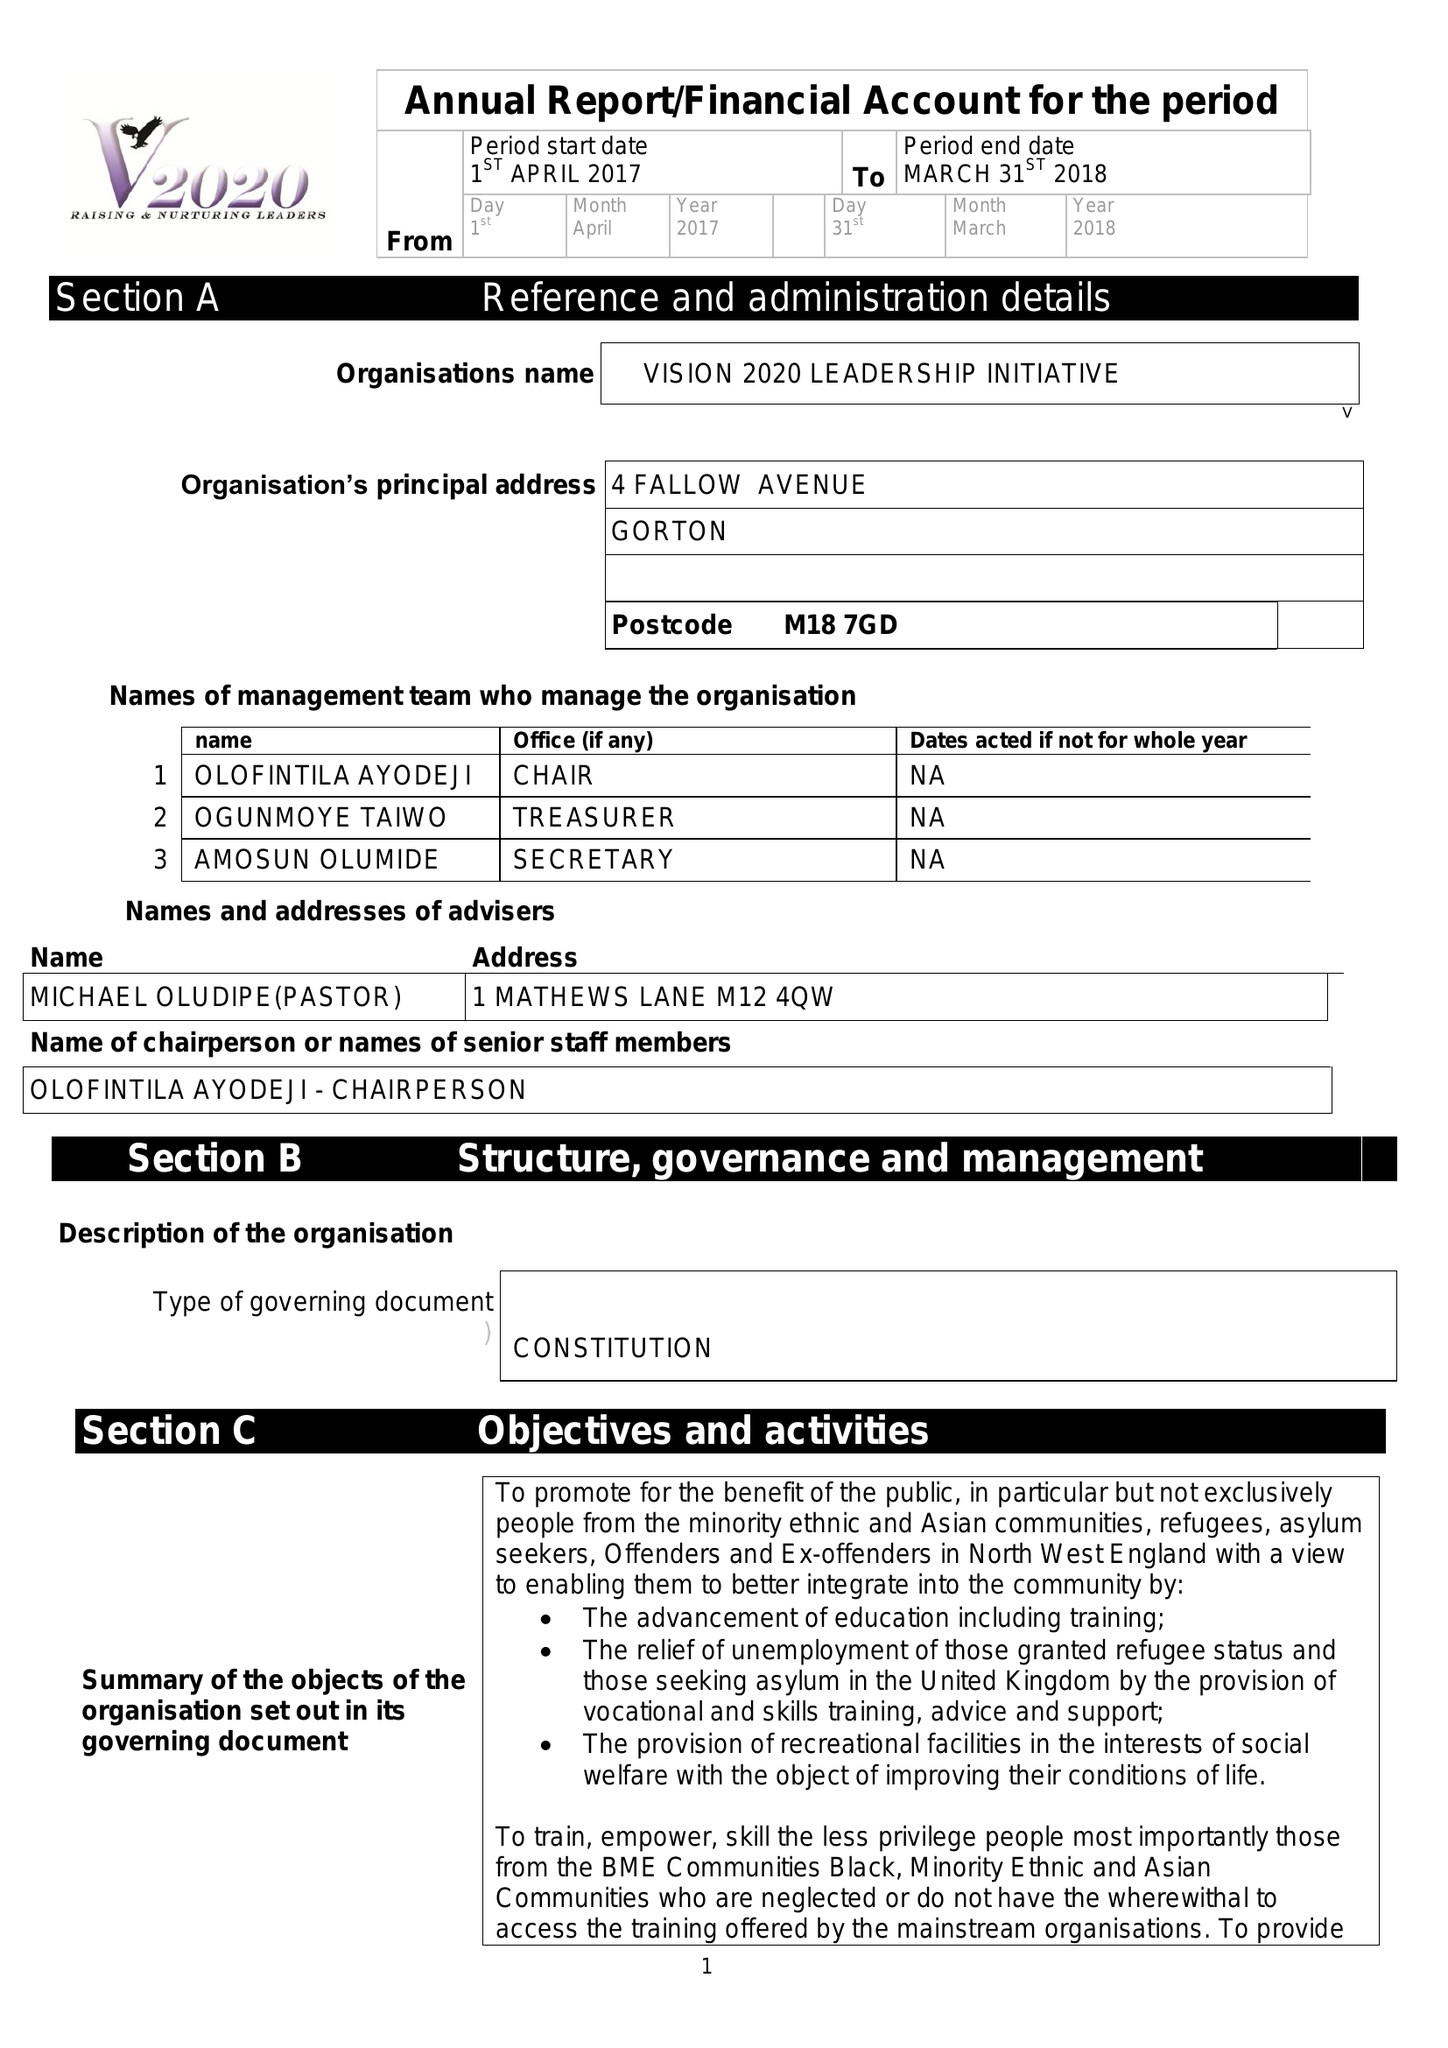What is the value for the address__street_line?
Answer the question using a single word or phrase. 4 FALLOW AVENUE 